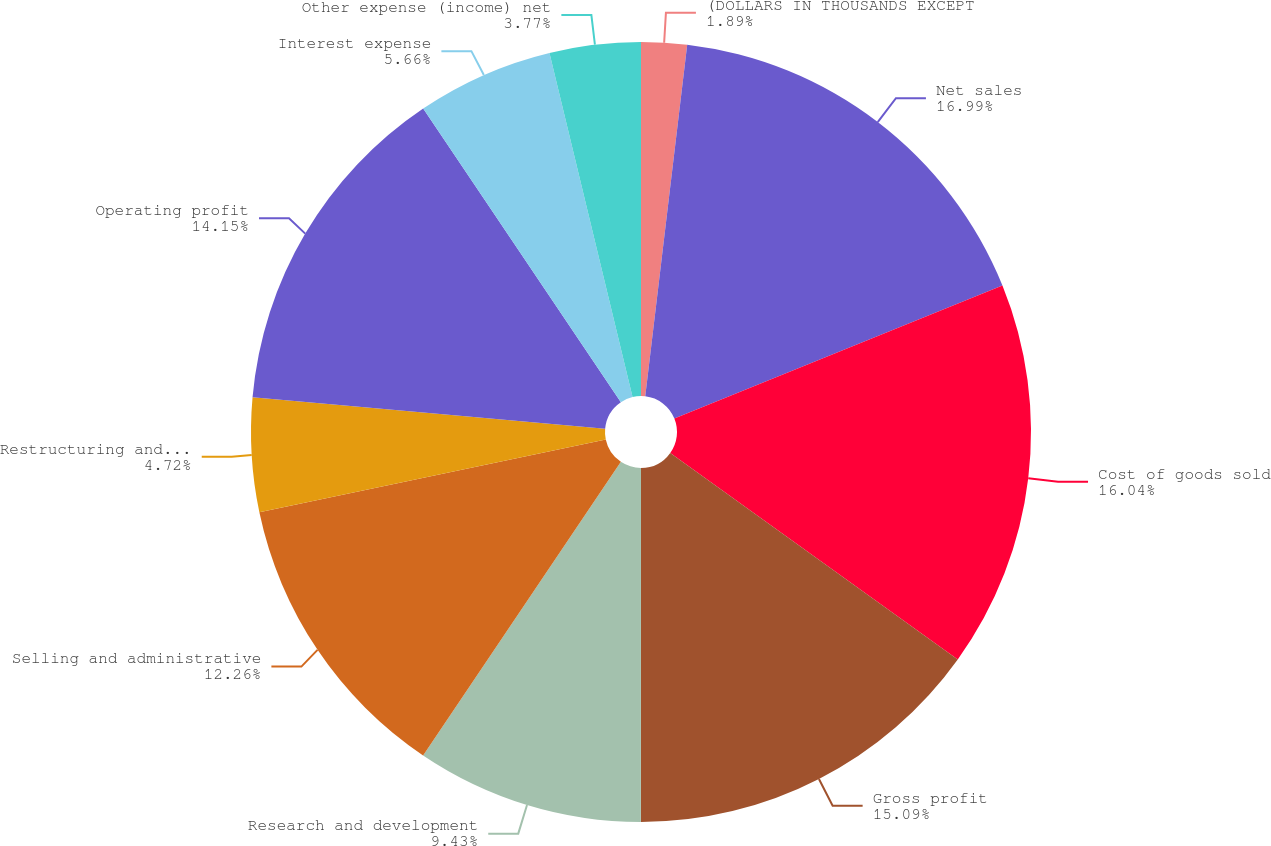Convert chart. <chart><loc_0><loc_0><loc_500><loc_500><pie_chart><fcel>(DOLLARS IN THOUSANDS EXCEPT<fcel>Net sales<fcel>Cost of goods sold<fcel>Gross profit<fcel>Research and development<fcel>Selling and administrative<fcel>Restructuring and other<fcel>Operating profit<fcel>Interest expense<fcel>Other expense (income) net<nl><fcel>1.89%<fcel>16.98%<fcel>16.04%<fcel>15.09%<fcel>9.43%<fcel>12.26%<fcel>4.72%<fcel>14.15%<fcel>5.66%<fcel>3.77%<nl></chart> 